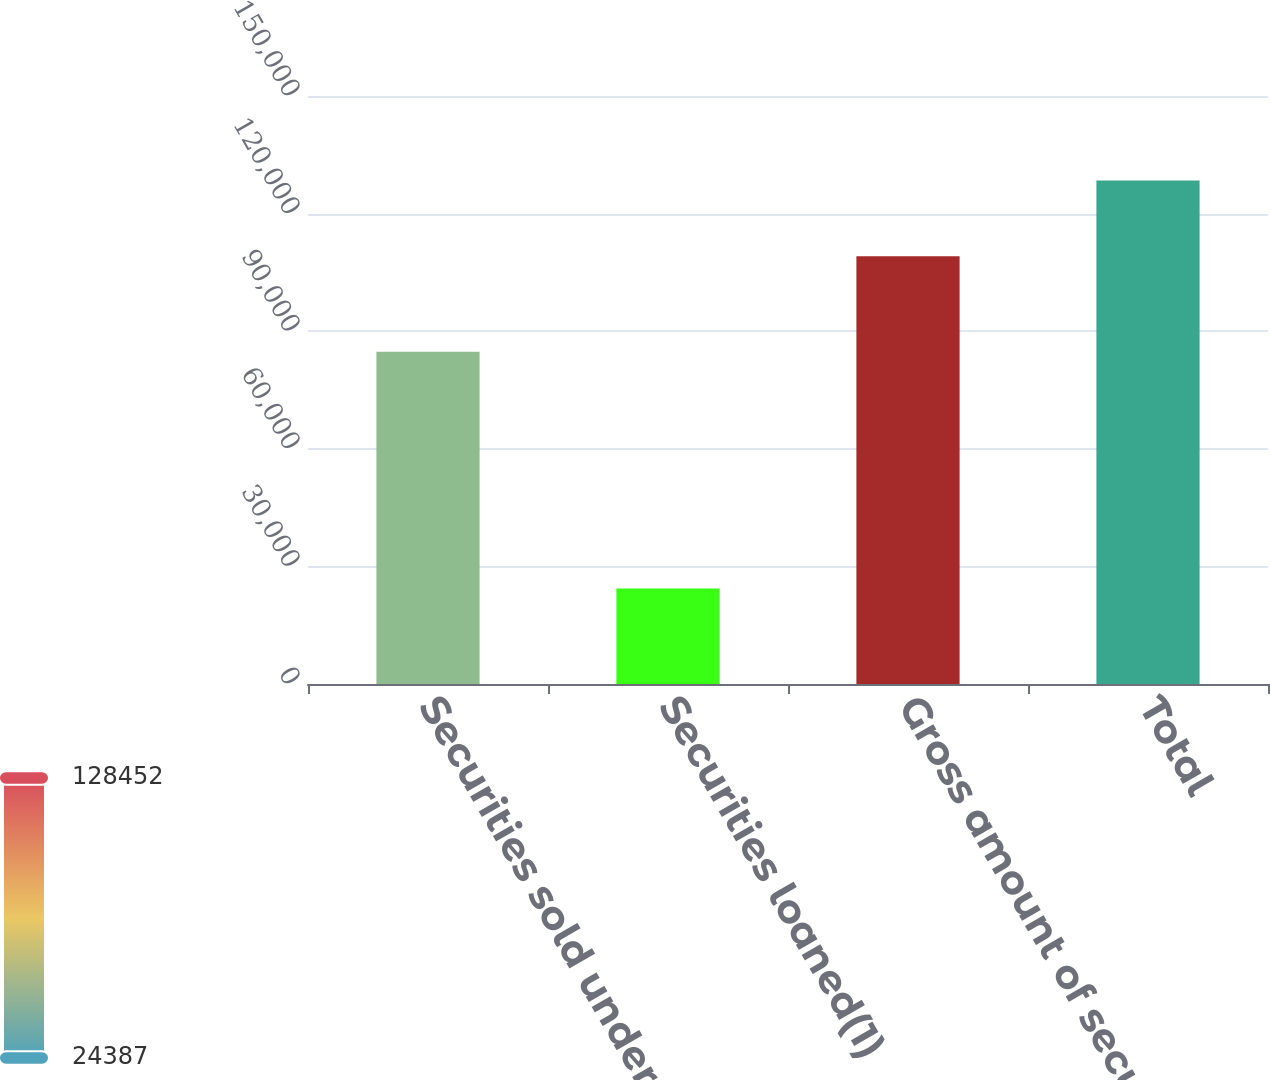Convert chart. <chart><loc_0><loc_0><loc_500><loc_500><bar_chart><fcel>Securities sold under<fcel>Securities loaned(1)<fcel>Gross amount of secured<fcel>Total<nl><fcel>84749<fcel>24387<fcel>109136<fcel>128452<nl></chart> 